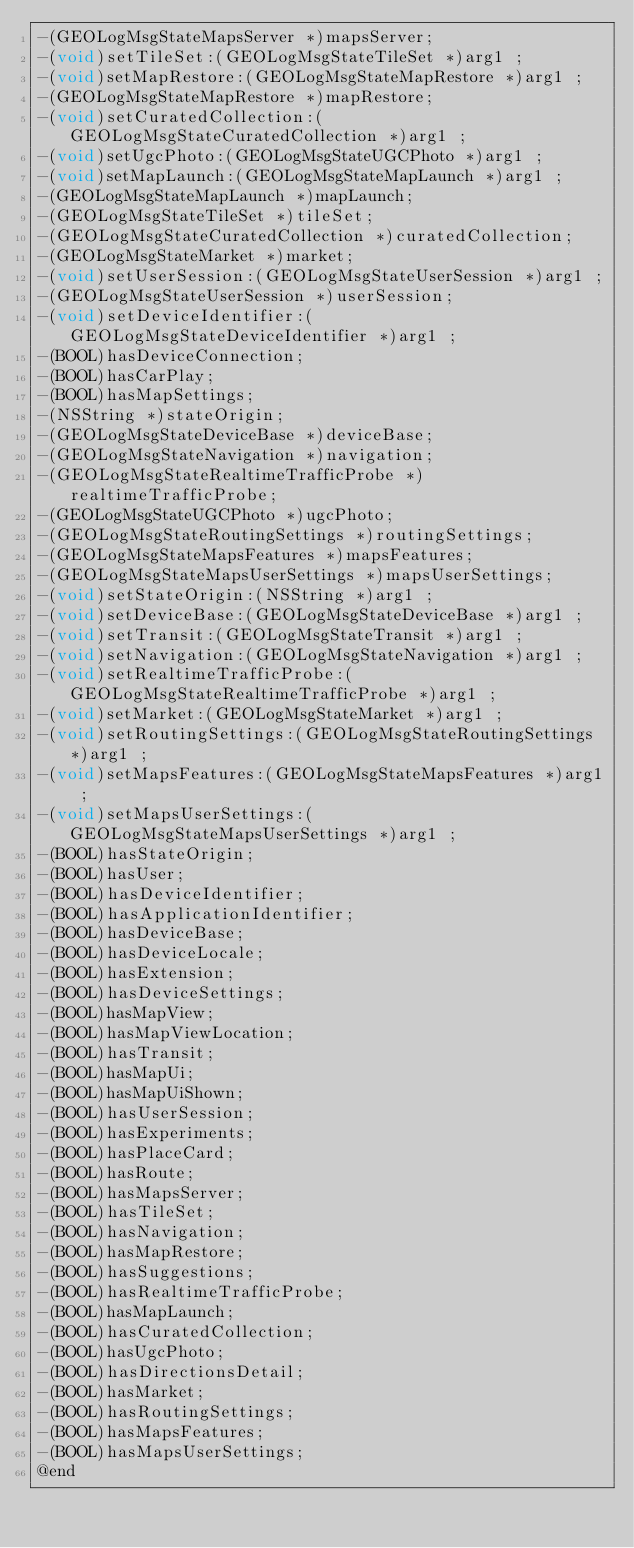Convert code to text. <code><loc_0><loc_0><loc_500><loc_500><_C_>-(GEOLogMsgStateMapsServer *)mapsServer;
-(void)setTileSet:(GEOLogMsgStateTileSet *)arg1 ;
-(void)setMapRestore:(GEOLogMsgStateMapRestore *)arg1 ;
-(GEOLogMsgStateMapRestore *)mapRestore;
-(void)setCuratedCollection:(GEOLogMsgStateCuratedCollection *)arg1 ;
-(void)setUgcPhoto:(GEOLogMsgStateUGCPhoto *)arg1 ;
-(void)setMapLaunch:(GEOLogMsgStateMapLaunch *)arg1 ;
-(GEOLogMsgStateMapLaunch *)mapLaunch;
-(GEOLogMsgStateTileSet *)tileSet;
-(GEOLogMsgStateCuratedCollection *)curatedCollection;
-(GEOLogMsgStateMarket *)market;
-(void)setUserSession:(GEOLogMsgStateUserSession *)arg1 ;
-(GEOLogMsgStateUserSession *)userSession;
-(void)setDeviceIdentifier:(GEOLogMsgStateDeviceIdentifier *)arg1 ;
-(BOOL)hasDeviceConnection;
-(BOOL)hasCarPlay;
-(BOOL)hasMapSettings;
-(NSString *)stateOrigin;
-(GEOLogMsgStateDeviceBase *)deviceBase;
-(GEOLogMsgStateNavigation *)navigation;
-(GEOLogMsgStateRealtimeTrafficProbe *)realtimeTrafficProbe;
-(GEOLogMsgStateUGCPhoto *)ugcPhoto;
-(GEOLogMsgStateRoutingSettings *)routingSettings;
-(GEOLogMsgStateMapsFeatures *)mapsFeatures;
-(GEOLogMsgStateMapsUserSettings *)mapsUserSettings;
-(void)setStateOrigin:(NSString *)arg1 ;
-(void)setDeviceBase:(GEOLogMsgStateDeviceBase *)arg1 ;
-(void)setTransit:(GEOLogMsgStateTransit *)arg1 ;
-(void)setNavigation:(GEOLogMsgStateNavigation *)arg1 ;
-(void)setRealtimeTrafficProbe:(GEOLogMsgStateRealtimeTrafficProbe *)arg1 ;
-(void)setMarket:(GEOLogMsgStateMarket *)arg1 ;
-(void)setRoutingSettings:(GEOLogMsgStateRoutingSettings *)arg1 ;
-(void)setMapsFeatures:(GEOLogMsgStateMapsFeatures *)arg1 ;
-(void)setMapsUserSettings:(GEOLogMsgStateMapsUserSettings *)arg1 ;
-(BOOL)hasStateOrigin;
-(BOOL)hasUser;
-(BOOL)hasDeviceIdentifier;
-(BOOL)hasApplicationIdentifier;
-(BOOL)hasDeviceBase;
-(BOOL)hasDeviceLocale;
-(BOOL)hasExtension;
-(BOOL)hasDeviceSettings;
-(BOOL)hasMapView;
-(BOOL)hasMapViewLocation;
-(BOOL)hasTransit;
-(BOOL)hasMapUi;
-(BOOL)hasMapUiShown;
-(BOOL)hasUserSession;
-(BOOL)hasExperiments;
-(BOOL)hasPlaceCard;
-(BOOL)hasRoute;
-(BOOL)hasMapsServer;
-(BOOL)hasTileSet;
-(BOOL)hasNavigation;
-(BOOL)hasMapRestore;
-(BOOL)hasSuggestions;
-(BOOL)hasRealtimeTrafficProbe;
-(BOOL)hasMapLaunch;
-(BOOL)hasCuratedCollection;
-(BOOL)hasUgcPhoto;
-(BOOL)hasDirectionsDetail;
-(BOOL)hasMarket;
-(BOOL)hasRoutingSettings;
-(BOOL)hasMapsFeatures;
-(BOOL)hasMapsUserSettings;
@end

</code> 